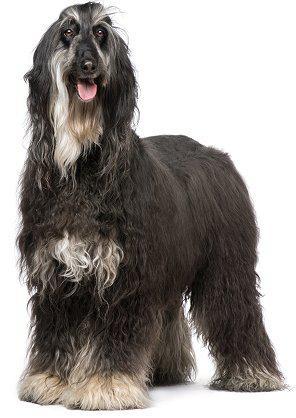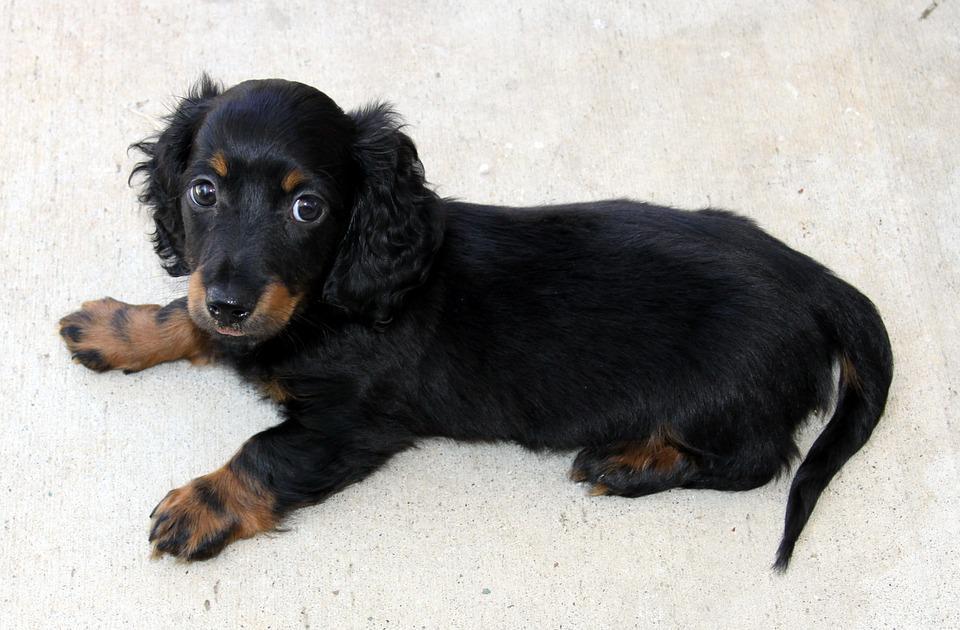The first image is the image on the left, the second image is the image on the right. For the images shown, is this caption "An image shows exactly one dog standing on all fours, and its fur is wavy-textured and dark grayish with paler markings." true? Answer yes or no. Yes. The first image is the image on the left, the second image is the image on the right. Given the left and right images, does the statement "A dog in one of the images is lying down." hold true? Answer yes or no. Yes. 